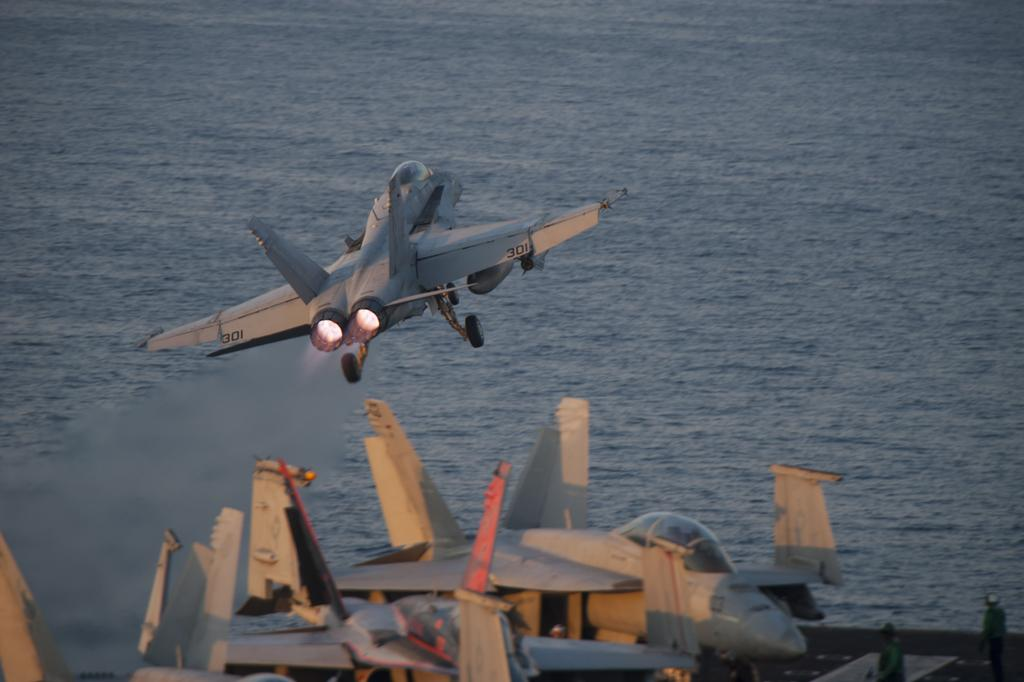What is the main subject of the image? The main subject of the image is airplanes. Can you describe the people in the image? There are two persons standing on a platform in the image. What is happening in the background of the image? An airplane is flying in the background of the image, and there is water visible as well. How many cows are present on the platform with the two persons? There are no cows present in the image; it only features airplanes, two persons, and a platform. What type of lift is being used by the airplane in the image? There is no lift visible in the image; the airplane is simply flying in the background. 